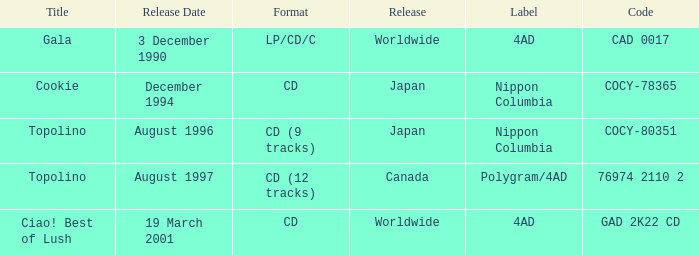What Label has a Code of cocy-78365? Nippon Columbia. 